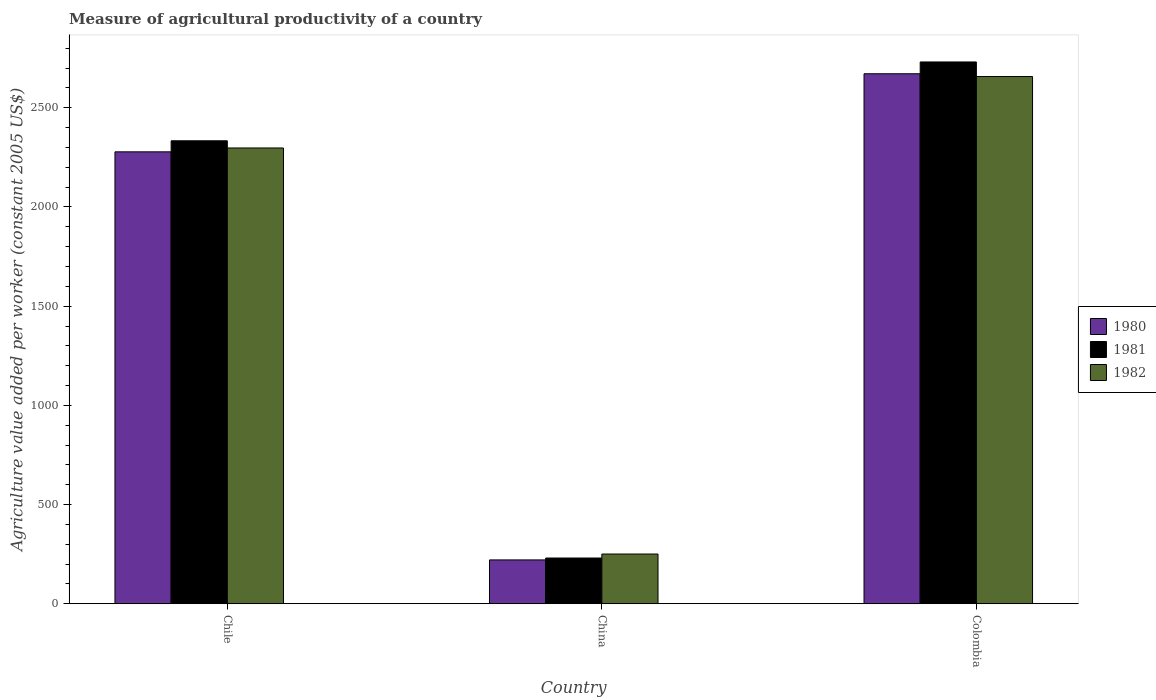How many groups of bars are there?
Make the answer very short. 3. Are the number of bars per tick equal to the number of legend labels?
Offer a terse response. Yes. Are the number of bars on each tick of the X-axis equal?
Provide a succinct answer. Yes. How many bars are there on the 1st tick from the right?
Offer a terse response. 3. What is the label of the 2nd group of bars from the left?
Provide a succinct answer. China. What is the measure of agricultural productivity in 1982 in China?
Offer a terse response. 250.55. Across all countries, what is the maximum measure of agricultural productivity in 1980?
Your answer should be compact. 2671.6. Across all countries, what is the minimum measure of agricultural productivity in 1980?
Give a very brief answer. 220.85. In which country was the measure of agricultural productivity in 1982 maximum?
Keep it short and to the point. Colombia. What is the total measure of agricultural productivity in 1982 in the graph?
Keep it short and to the point. 5205.57. What is the difference between the measure of agricultural productivity in 1981 in Chile and that in Colombia?
Offer a terse response. -397.34. What is the difference between the measure of agricultural productivity in 1982 in China and the measure of agricultural productivity in 1980 in Chile?
Provide a succinct answer. -2027.43. What is the average measure of agricultural productivity in 1980 per country?
Provide a succinct answer. 1723.48. What is the difference between the measure of agricultural productivity of/in 1981 and measure of agricultural productivity of/in 1980 in China?
Offer a terse response. 9.53. In how many countries, is the measure of agricultural productivity in 1982 greater than 2300 US$?
Give a very brief answer. 1. What is the ratio of the measure of agricultural productivity in 1980 in China to that in Colombia?
Make the answer very short. 0.08. Is the difference between the measure of agricultural productivity in 1981 in China and Colombia greater than the difference between the measure of agricultural productivity in 1980 in China and Colombia?
Your answer should be very brief. No. What is the difference between the highest and the second highest measure of agricultural productivity in 1980?
Give a very brief answer. -2057.13. What is the difference between the highest and the lowest measure of agricultural productivity in 1982?
Provide a short and direct response. 2407.01. In how many countries, is the measure of agricultural productivity in 1981 greater than the average measure of agricultural productivity in 1981 taken over all countries?
Provide a succinct answer. 2. Is the sum of the measure of agricultural productivity in 1981 in Chile and Colombia greater than the maximum measure of agricultural productivity in 1980 across all countries?
Give a very brief answer. Yes. What does the 2nd bar from the right in China represents?
Keep it short and to the point. 1981. Are all the bars in the graph horizontal?
Your answer should be very brief. No. What is the difference between two consecutive major ticks on the Y-axis?
Keep it short and to the point. 500. Does the graph contain grids?
Provide a succinct answer. No. How are the legend labels stacked?
Offer a very short reply. Vertical. What is the title of the graph?
Offer a terse response. Measure of agricultural productivity of a country. Does "1978" appear as one of the legend labels in the graph?
Offer a terse response. No. What is the label or title of the Y-axis?
Ensure brevity in your answer.  Agriculture value added per worker (constant 2005 US$). What is the Agriculture value added per worker (constant 2005 US$) of 1980 in Chile?
Keep it short and to the point. 2277.98. What is the Agriculture value added per worker (constant 2005 US$) of 1981 in Chile?
Provide a short and direct response. 2333.68. What is the Agriculture value added per worker (constant 2005 US$) in 1982 in Chile?
Your answer should be compact. 2297.45. What is the Agriculture value added per worker (constant 2005 US$) of 1980 in China?
Your answer should be very brief. 220.85. What is the Agriculture value added per worker (constant 2005 US$) in 1981 in China?
Offer a terse response. 230.38. What is the Agriculture value added per worker (constant 2005 US$) in 1982 in China?
Make the answer very short. 250.55. What is the Agriculture value added per worker (constant 2005 US$) in 1980 in Colombia?
Your answer should be very brief. 2671.6. What is the Agriculture value added per worker (constant 2005 US$) of 1981 in Colombia?
Provide a succinct answer. 2731.02. What is the Agriculture value added per worker (constant 2005 US$) of 1982 in Colombia?
Provide a succinct answer. 2657.56. Across all countries, what is the maximum Agriculture value added per worker (constant 2005 US$) of 1980?
Ensure brevity in your answer.  2671.6. Across all countries, what is the maximum Agriculture value added per worker (constant 2005 US$) in 1981?
Offer a terse response. 2731.02. Across all countries, what is the maximum Agriculture value added per worker (constant 2005 US$) in 1982?
Your answer should be very brief. 2657.56. Across all countries, what is the minimum Agriculture value added per worker (constant 2005 US$) in 1980?
Your response must be concise. 220.85. Across all countries, what is the minimum Agriculture value added per worker (constant 2005 US$) of 1981?
Your answer should be very brief. 230.38. Across all countries, what is the minimum Agriculture value added per worker (constant 2005 US$) in 1982?
Provide a succinct answer. 250.55. What is the total Agriculture value added per worker (constant 2005 US$) in 1980 in the graph?
Give a very brief answer. 5170.43. What is the total Agriculture value added per worker (constant 2005 US$) of 1981 in the graph?
Keep it short and to the point. 5295.08. What is the total Agriculture value added per worker (constant 2005 US$) in 1982 in the graph?
Your answer should be very brief. 5205.57. What is the difference between the Agriculture value added per worker (constant 2005 US$) in 1980 in Chile and that in China?
Give a very brief answer. 2057.13. What is the difference between the Agriculture value added per worker (constant 2005 US$) of 1981 in Chile and that in China?
Your answer should be very brief. 2103.3. What is the difference between the Agriculture value added per worker (constant 2005 US$) of 1982 in Chile and that in China?
Provide a succinct answer. 2046.9. What is the difference between the Agriculture value added per worker (constant 2005 US$) of 1980 in Chile and that in Colombia?
Ensure brevity in your answer.  -393.61. What is the difference between the Agriculture value added per worker (constant 2005 US$) of 1981 in Chile and that in Colombia?
Your answer should be compact. -397.34. What is the difference between the Agriculture value added per worker (constant 2005 US$) in 1982 in Chile and that in Colombia?
Offer a very short reply. -360.11. What is the difference between the Agriculture value added per worker (constant 2005 US$) of 1980 in China and that in Colombia?
Ensure brevity in your answer.  -2450.74. What is the difference between the Agriculture value added per worker (constant 2005 US$) of 1981 in China and that in Colombia?
Your answer should be compact. -2500.64. What is the difference between the Agriculture value added per worker (constant 2005 US$) in 1982 in China and that in Colombia?
Offer a terse response. -2407.01. What is the difference between the Agriculture value added per worker (constant 2005 US$) of 1980 in Chile and the Agriculture value added per worker (constant 2005 US$) of 1981 in China?
Provide a short and direct response. 2047.6. What is the difference between the Agriculture value added per worker (constant 2005 US$) of 1980 in Chile and the Agriculture value added per worker (constant 2005 US$) of 1982 in China?
Your response must be concise. 2027.43. What is the difference between the Agriculture value added per worker (constant 2005 US$) in 1981 in Chile and the Agriculture value added per worker (constant 2005 US$) in 1982 in China?
Keep it short and to the point. 2083.13. What is the difference between the Agriculture value added per worker (constant 2005 US$) of 1980 in Chile and the Agriculture value added per worker (constant 2005 US$) of 1981 in Colombia?
Make the answer very short. -453.04. What is the difference between the Agriculture value added per worker (constant 2005 US$) of 1980 in Chile and the Agriculture value added per worker (constant 2005 US$) of 1982 in Colombia?
Your answer should be compact. -379.58. What is the difference between the Agriculture value added per worker (constant 2005 US$) of 1981 in Chile and the Agriculture value added per worker (constant 2005 US$) of 1982 in Colombia?
Keep it short and to the point. -323.88. What is the difference between the Agriculture value added per worker (constant 2005 US$) of 1980 in China and the Agriculture value added per worker (constant 2005 US$) of 1981 in Colombia?
Your answer should be compact. -2510.17. What is the difference between the Agriculture value added per worker (constant 2005 US$) in 1980 in China and the Agriculture value added per worker (constant 2005 US$) in 1982 in Colombia?
Provide a short and direct response. -2436.71. What is the difference between the Agriculture value added per worker (constant 2005 US$) of 1981 in China and the Agriculture value added per worker (constant 2005 US$) of 1982 in Colombia?
Your answer should be very brief. -2427.18. What is the average Agriculture value added per worker (constant 2005 US$) in 1980 per country?
Give a very brief answer. 1723.48. What is the average Agriculture value added per worker (constant 2005 US$) of 1981 per country?
Provide a succinct answer. 1765.03. What is the average Agriculture value added per worker (constant 2005 US$) of 1982 per country?
Make the answer very short. 1735.19. What is the difference between the Agriculture value added per worker (constant 2005 US$) of 1980 and Agriculture value added per worker (constant 2005 US$) of 1981 in Chile?
Provide a succinct answer. -55.7. What is the difference between the Agriculture value added per worker (constant 2005 US$) in 1980 and Agriculture value added per worker (constant 2005 US$) in 1982 in Chile?
Your answer should be very brief. -19.47. What is the difference between the Agriculture value added per worker (constant 2005 US$) of 1981 and Agriculture value added per worker (constant 2005 US$) of 1982 in Chile?
Offer a terse response. 36.23. What is the difference between the Agriculture value added per worker (constant 2005 US$) in 1980 and Agriculture value added per worker (constant 2005 US$) in 1981 in China?
Offer a terse response. -9.53. What is the difference between the Agriculture value added per worker (constant 2005 US$) of 1980 and Agriculture value added per worker (constant 2005 US$) of 1982 in China?
Provide a succinct answer. -29.7. What is the difference between the Agriculture value added per worker (constant 2005 US$) of 1981 and Agriculture value added per worker (constant 2005 US$) of 1982 in China?
Offer a very short reply. -20.17. What is the difference between the Agriculture value added per worker (constant 2005 US$) of 1980 and Agriculture value added per worker (constant 2005 US$) of 1981 in Colombia?
Make the answer very short. -59.42. What is the difference between the Agriculture value added per worker (constant 2005 US$) in 1980 and Agriculture value added per worker (constant 2005 US$) in 1982 in Colombia?
Make the answer very short. 14.03. What is the difference between the Agriculture value added per worker (constant 2005 US$) in 1981 and Agriculture value added per worker (constant 2005 US$) in 1982 in Colombia?
Ensure brevity in your answer.  73.46. What is the ratio of the Agriculture value added per worker (constant 2005 US$) in 1980 in Chile to that in China?
Your answer should be very brief. 10.31. What is the ratio of the Agriculture value added per worker (constant 2005 US$) in 1981 in Chile to that in China?
Offer a terse response. 10.13. What is the ratio of the Agriculture value added per worker (constant 2005 US$) in 1982 in Chile to that in China?
Keep it short and to the point. 9.17. What is the ratio of the Agriculture value added per worker (constant 2005 US$) in 1980 in Chile to that in Colombia?
Your answer should be compact. 0.85. What is the ratio of the Agriculture value added per worker (constant 2005 US$) of 1981 in Chile to that in Colombia?
Give a very brief answer. 0.85. What is the ratio of the Agriculture value added per worker (constant 2005 US$) of 1982 in Chile to that in Colombia?
Give a very brief answer. 0.86. What is the ratio of the Agriculture value added per worker (constant 2005 US$) of 1980 in China to that in Colombia?
Offer a very short reply. 0.08. What is the ratio of the Agriculture value added per worker (constant 2005 US$) in 1981 in China to that in Colombia?
Offer a terse response. 0.08. What is the ratio of the Agriculture value added per worker (constant 2005 US$) in 1982 in China to that in Colombia?
Your answer should be very brief. 0.09. What is the difference between the highest and the second highest Agriculture value added per worker (constant 2005 US$) of 1980?
Ensure brevity in your answer.  393.61. What is the difference between the highest and the second highest Agriculture value added per worker (constant 2005 US$) of 1981?
Keep it short and to the point. 397.34. What is the difference between the highest and the second highest Agriculture value added per worker (constant 2005 US$) of 1982?
Ensure brevity in your answer.  360.11. What is the difference between the highest and the lowest Agriculture value added per worker (constant 2005 US$) of 1980?
Give a very brief answer. 2450.74. What is the difference between the highest and the lowest Agriculture value added per worker (constant 2005 US$) of 1981?
Provide a succinct answer. 2500.64. What is the difference between the highest and the lowest Agriculture value added per worker (constant 2005 US$) in 1982?
Ensure brevity in your answer.  2407.01. 